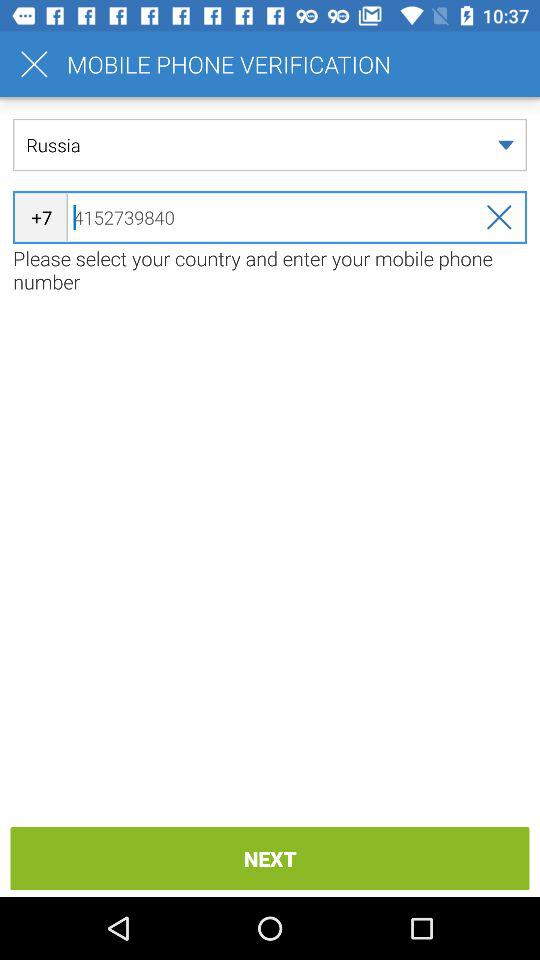What is the mobile phone number? The mobile phone number is +7 4152739840. 